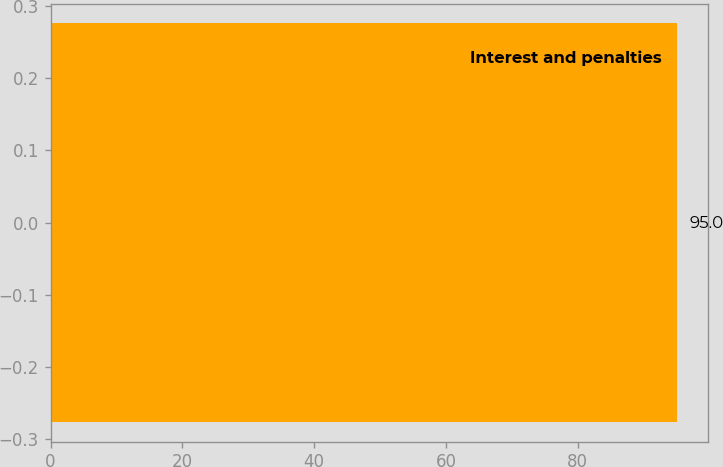Convert chart to OTSL. <chart><loc_0><loc_0><loc_500><loc_500><bar_chart><fcel>Interest and penalties<nl><fcel>95<nl></chart> 